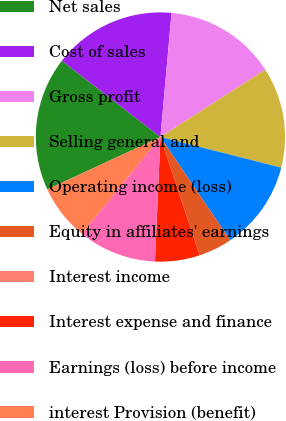Convert chart to OTSL. <chart><loc_0><loc_0><loc_500><loc_500><pie_chart><fcel>Net sales<fcel>Cost of sales<fcel>Gross profit<fcel>Selling general and<fcel>Operating income (loss)<fcel>Equity in affiliates' earnings<fcel>Interest income<fcel>Interest expense and finance<fcel>Earnings (loss) before income<fcel>interest Provision (benefit)<nl><fcel>17.39%<fcel>15.94%<fcel>14.49%<fcel>13.04%<fcel>11.59%<fcel>4.35%<fcel>0.01%<fcel>5.8%<fcel>10.14%<fcel>7.25%<nl></chart> 